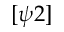<formula> <loc_0><loc_0><loc_500><loc_500>[ \psi 2 ]</formula> 